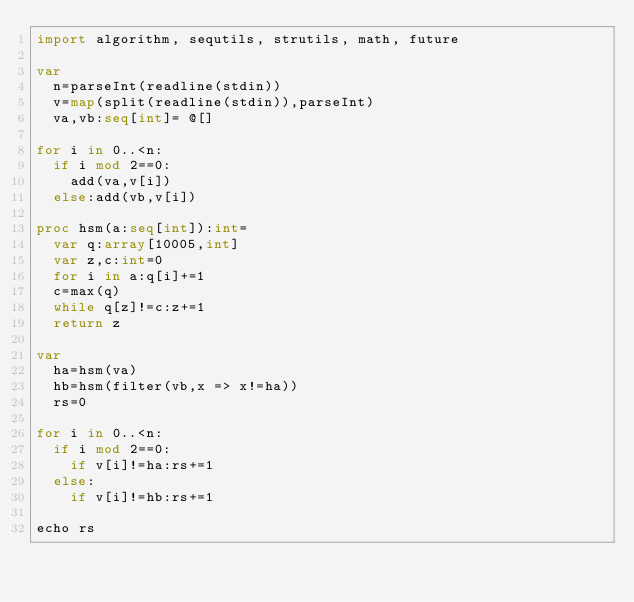Convert code to text. <code><loc_0><loc_0><loc_500><loc_500><_Nim_>import algorithm, sequtils, strutils, math, future
 
var
  n=parseInt(readline(stdin))
  v=map(split(readline(stdin)),parseInt)
  va,vb:seq[int]= @[]
  
for i in 0..<n:
  if i mod 2==0:
    add(va,v[i])
  else:add(vb,v[i])

proc hsm(a:seq[int]):int=
  var q:array[10005,int]
  var z,c:int=0
  for i in a:q[i]+=1
  c=max(q)
  while q[z]!=c:z+=1
  return z
 
var
  ha=hsm(va)
  hb=hsm(filter(vb,x => x!=ha))
  rs=0

for i in 0..<n:
  if i mod 2==0:
    if v[i]!=ha:rs+=1
  else:
    if v[i]!=hb:rs+=1
    
echo rs</code> 